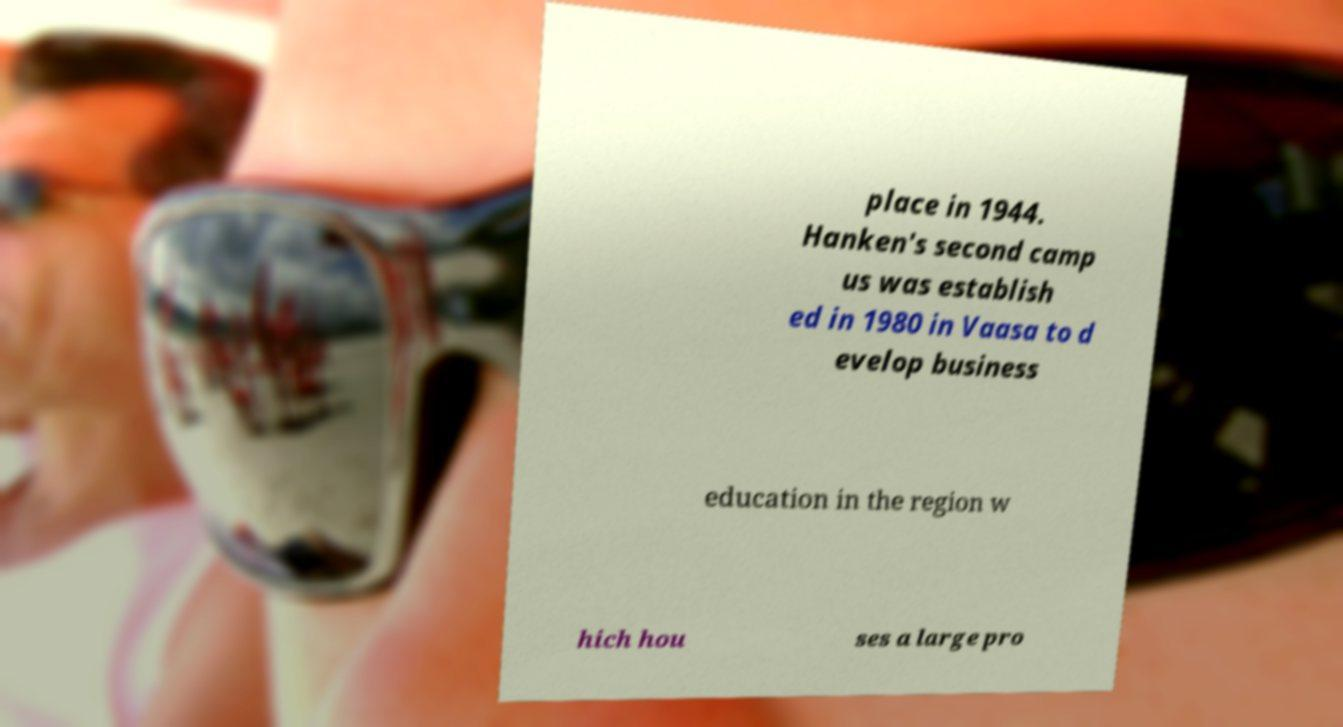Can you read and provide the text displayed in the image?This photo seems to have some interesting text. Can you extract and type it out for me? place in 1944. Hanken's second camp us was establish ed in 1980 in Vaasa to d evelop business education in the region w hich hou ses a large pro 